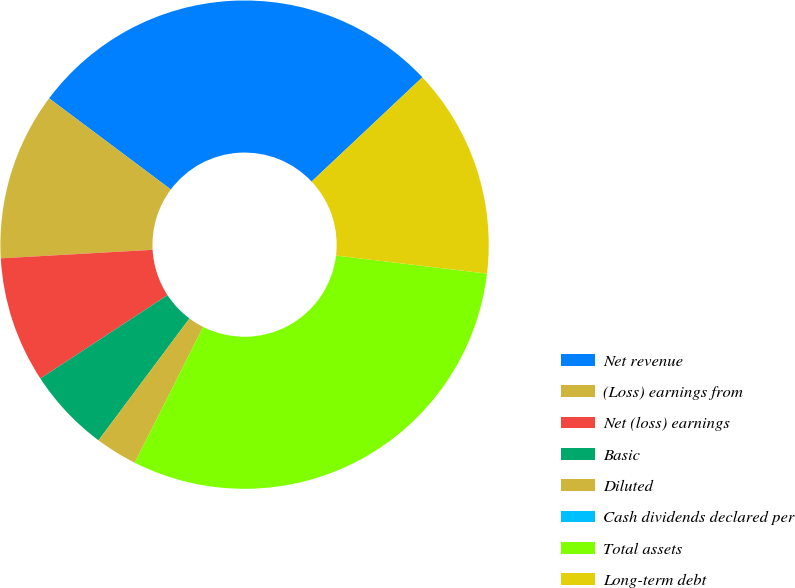Convert chart. <chart><loc_0><loc_0><loc_500><loc_500><pie_chart><fcel>Net revenue<fcel>(Loss) earnings from<fcel>Net (loss) earnings<fcel>Basic<fcel>Diluted<fcel>Cash dividends declared per<fcel>Total assets<fcel>Long-term debt<nl><fcel>27.75%<fcel>11.12%<fcel>8.34%<fcel>5.56%<fcel>2.78%<fcel>0.0%<fcel>30.53%<fcel>13.91%<nl></chart> 